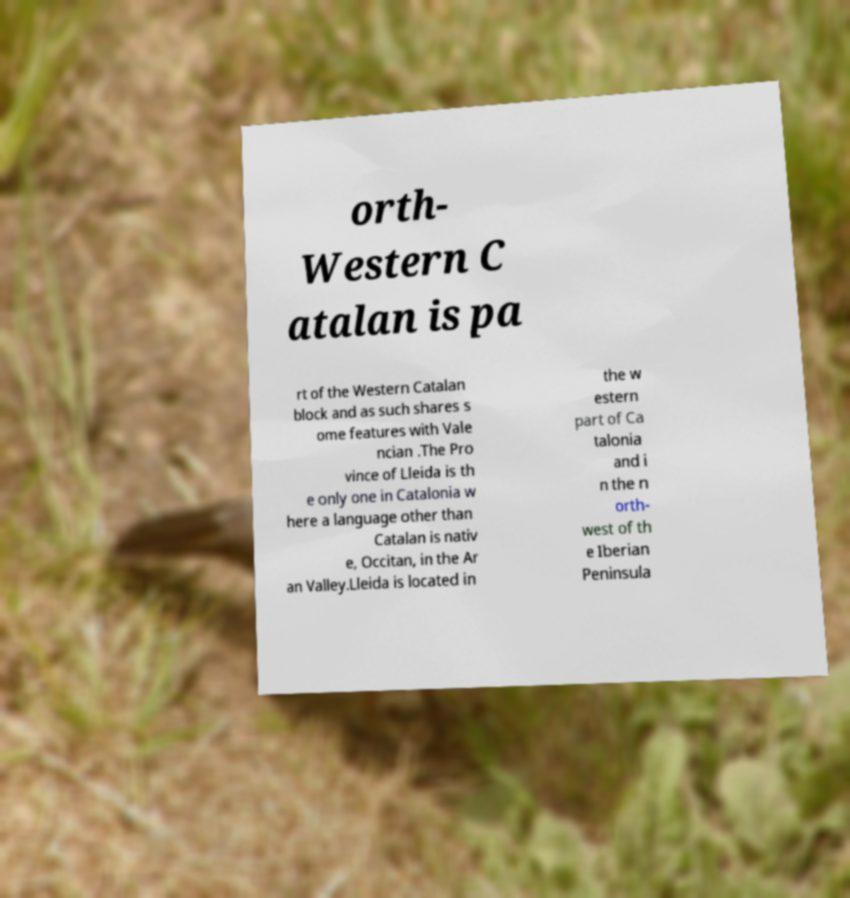I need the written content from this picture converted into text. Can you do that? orth- Western C atalan is pa rt of the Western Catalan block and as such shares s ome features with Vale ncian .The Pro vince of Lleida is th e only one in Catalonia w here a language other than Catalan is nativ e, Occitan, in the Ar an Valley.Lleida is located in the w estern part of Ca talonia and i n the n orth- west of th e Iberian Peninsula 